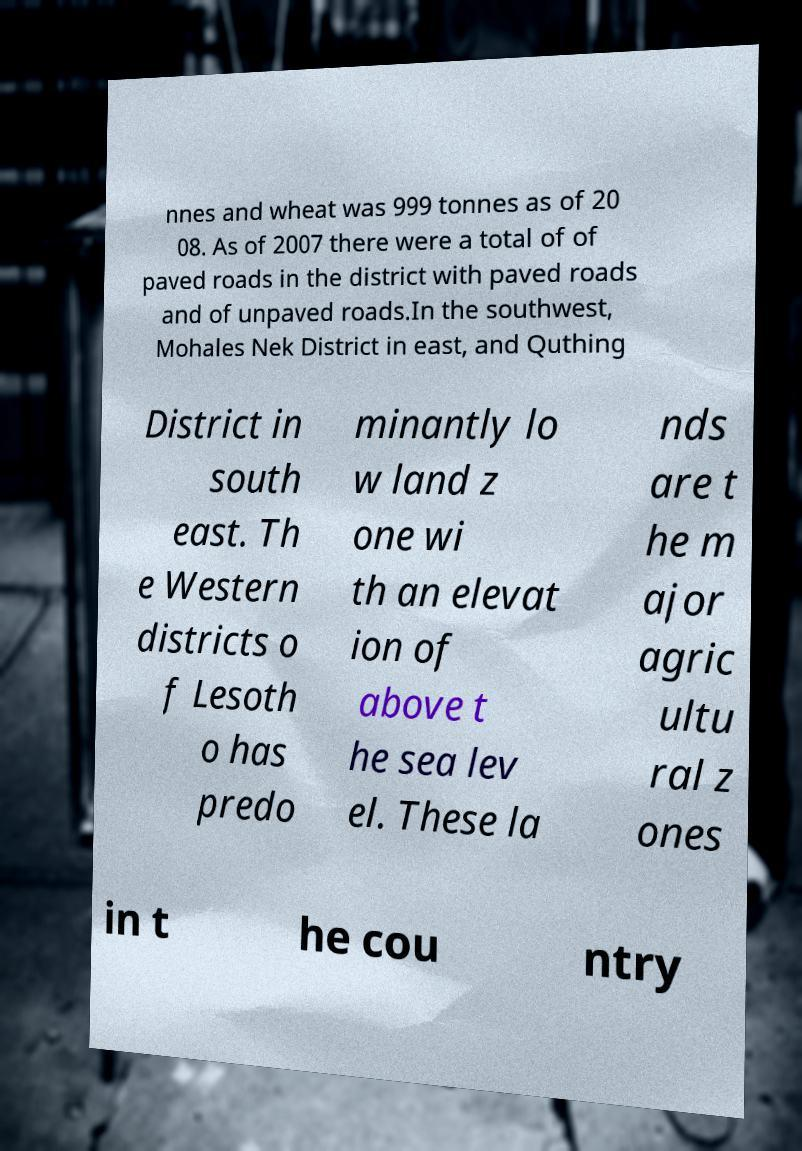For documentation purposes, I need the text within this image transcribed. Could you provide that? nnes and wheat was 999 tonnes as of 20 08. As of 2007 there were a total of of paved roads in the district with paved roads and of unpaved roads.In the southwest, Mohales Nek District in east, and Quthing District in south east. Th e Western districts o f Lesoth o has predo minantly lo w land z one wi th an elevat ion of above t he sea lev el. These la nds are t he m ajor agric ultu ral z ones in t he cou ntry 